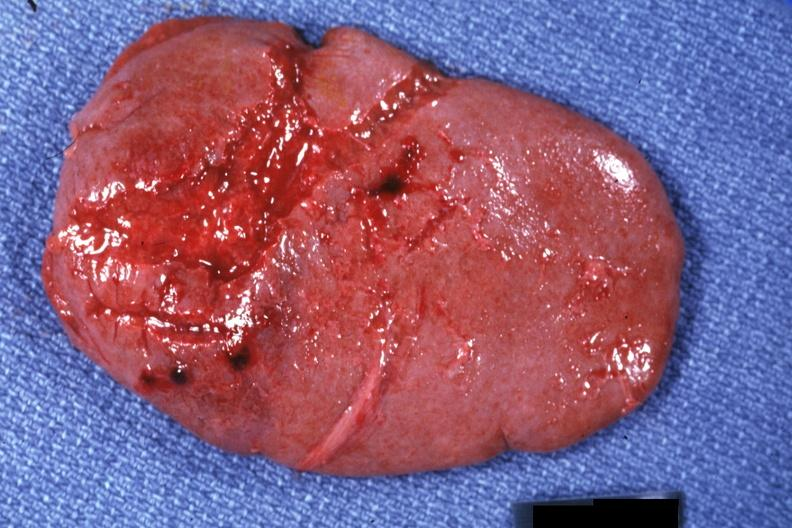what is present?
Answer the question using a single word or phrase. Hematologic 